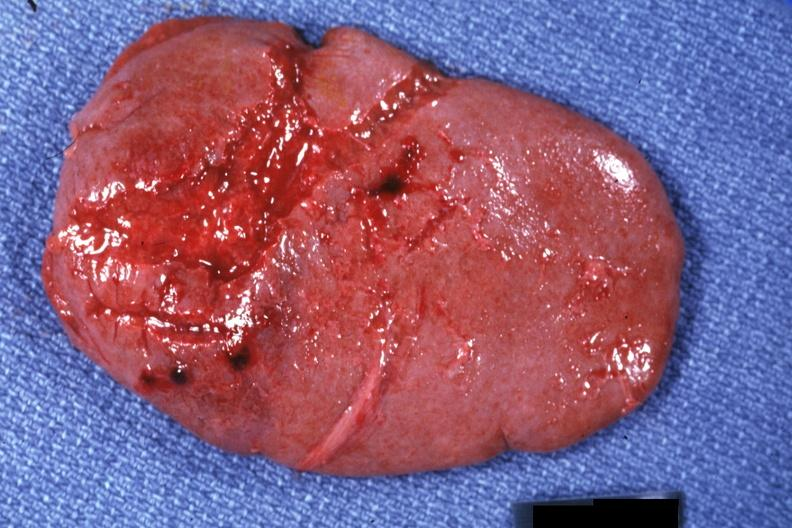what is present?
Answer the question using a single word or phrase. Hematologic 